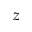<formula> <loc_0><loc_0><loc_500><loc_500>z</formula> 